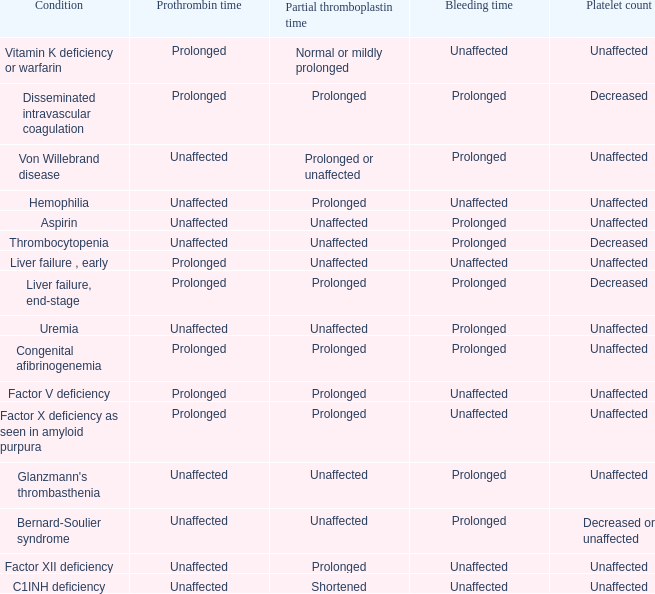What ailment exhibits unchanged bleeding time, protracted partial thromboplastin time, and unmodified prothrombin time? Hemophilia, Factor XII deficiency. 